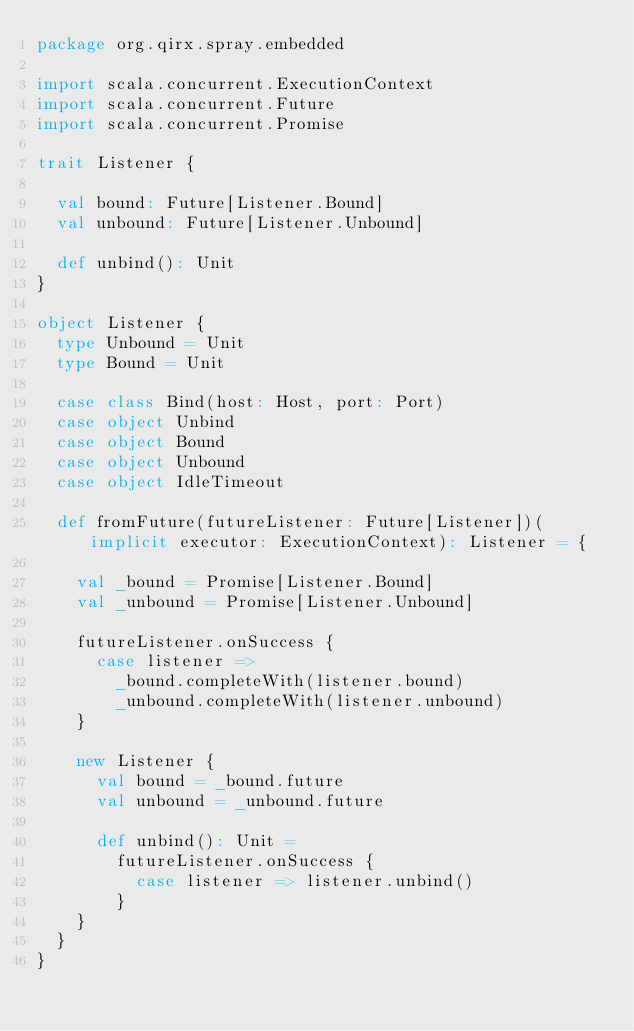<code> <loc_0><loc_0><loc_500><loc_500><_Scala_>package org.qirx.spray.embedded

import scala.concurrent.ExecutionContext
import scala.concurrent.Future
import scala.concurrent.Promise

trait Listener {

  val bound: Future[Listener.Bound]
  val unbound: Future[Listener.Unbound]

  def unbind(): Unit
}

object Listener {
  type Unbound = Unit
  type Bound = Unit

  case class Bind(host: Host, port: Port)
  case object Unbind
  case object Bound
  case object Unbound
  case object IdleTimeout

  def fromFuture(futureListener: Future[Listener])(implicit executor: ExecutionContext): Listener = {

    val _bound = Promise[Listener.Bound]
    val _unbound = Promise[Listener.Unbound]

    futureListener.onSuccess {
      case listener =>
        _bound.completeWith(listener.bound)
        _unbound.completeWith(listener.unbound)
    }

    new Listener {
      val bound = _bound.future
      val unbound = _unbound.future

      def unbind(): Unit =
        futureListener.onSuccess {
          case listener => listener.unbind()
        }
    }
  }
}</code> 